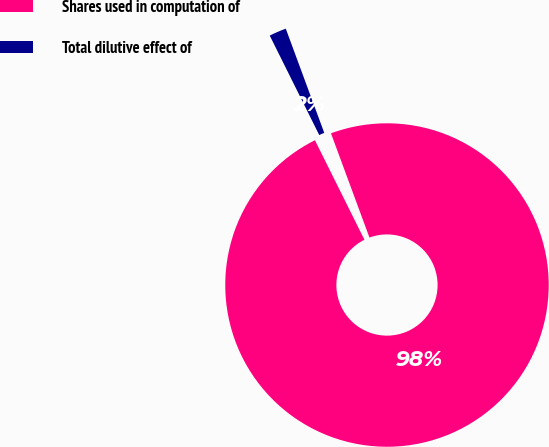Convert chart to OTSL. <chart><loc_0><loc_0><loc_500><loc_500><pie_chart><fcel>Shares used in computation of<fcel>Total dilutive effect of<nl><fcel>98.28%<fcel>1.72%<nl></chart> 